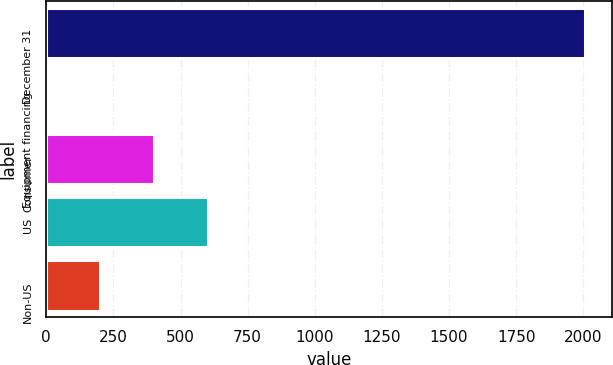Convert chart to OTSL. <chart><loc_0><loc_0><loc_500><loc_500><bar_chart><fcel>December 31<fcel>Equipment financing<fcel>Consumer<fcel>US<fcel>Non-US<nl><fcel>2007<fcel>1.21<fcel>402.37<fcel>602.95<fcel>201.79<nl></chart> 